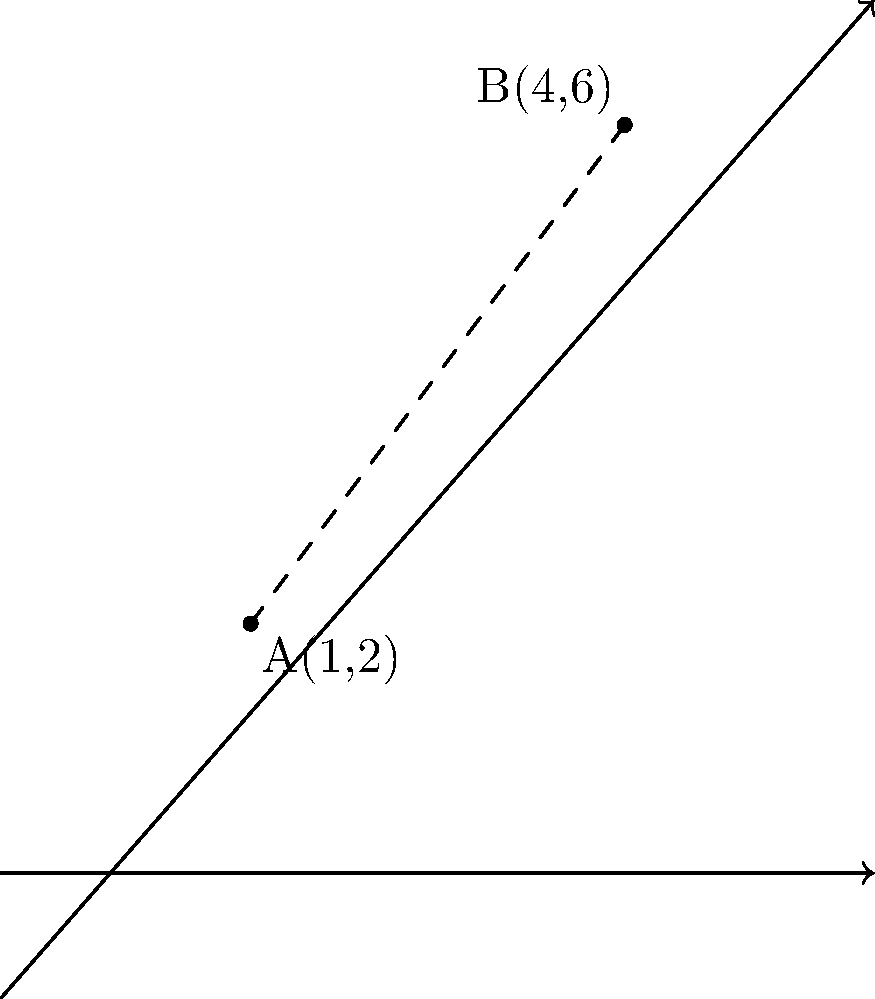In the context of fact-checking digital media sources, consider two credible news outlets represented as points A(1,2) and B(4,6) on a coordinate plane. The distance between these points represents the degree of agreement in their reporting of a particular story. Calculate the exact distance between these two points using the distance formula. How might this distance inform a journalist's approach to verifying information from these sources? To solve this problem, we'll use the distance formula derived from the Pythagorean theorem:

1) The distance formula is:
   $$d = \sqrt{(x_2 - x_1)^2 + (y_2 - y_1)^2}$$

2) We have:
   Point A: $(x_1, y_1) = (1, 2)$
   Point B: $(x_2, y_2) = (4, 6)$

3) Let's substitute these values into the formula:
   $$d = \sqrt{(4 - 1)^2 + (6 - 2)^2}$$

4) Simplify inside the parentheses:
   $$d = \sqrt{3^2 + 4^2}$$

5) Calculate the squares:
   $$d = \sqrt{9 + 16}$$

6) Add under the square root:
   $$d = \sqrt{25}$$

7) Simplify:
   $$d = 5$$

The distance between the two points is 5 units.

In the context of journalism, this distance could represent the degree of discrepancy between two sources' reporting. A smaller distance might indicate more agreement, while a larger distance could suggest conflicting information. This mathematical approach to comparing sources emphasizes the importance of consulting multiple credible outlets and critically analyzing discrepancies in reporting to ensure accurate fact-checking in digital media.
Answer: 5 units 